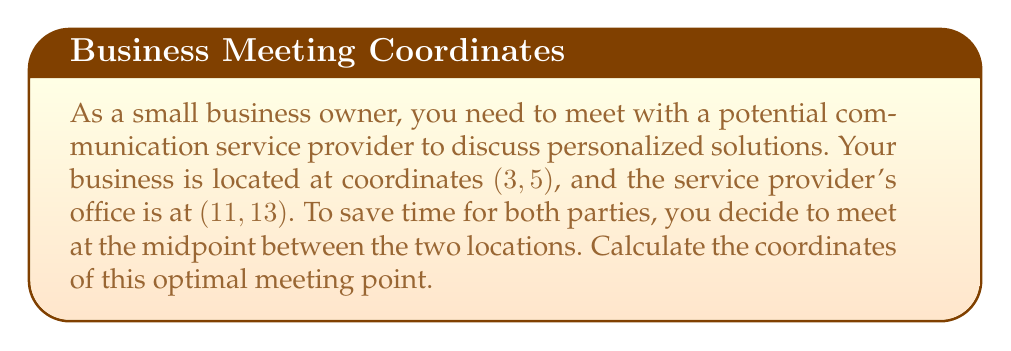Teach me how to tackle this problem. To find the midpoint between two points in a coordinate system, we use the midpoint formula:

$$\text{Midpoint} = (\frac{x_1 + x_2}{2}, \frac{y_1 + y_2}{2})$$

Where $(x_1, y_1)$ is the first point and $(x_2, y_2)$ is the second point.

In this case:
$(x_1, y_1) = (3, 5)$ (your business location)
$(x_2, y_2) = (11, 13)$ (service provider's office)

Let's calculate the x-coordinate of the midpoint:
$$x = \frac{x_1 + x_2}{2} = \frac{3 + 11}{2} = \frac{14}{2} = 7$$

Now, let's calculate the y-coordinate of the midpoint:
$$y = \frac{y_1 + y_2}{2} = \frac{5 + 13}{2} = \frac{18}{2} = 9$$

Therefore, the midpoint coordinates are (7, 9).

[asy]
unitsize(1cm);
dot((3,5));
dot((11,13));
dot((7,9),red);
label("(3,5)", (3,5), SW);
label("(11,13)", (11,13), NE);
label("(7,9)", (7,9), SE);
draw((3,5)--(11,13), dashed);
draw((0,0)--(12,14), Arrow);
draw((0,0)--(0,14), Arrow);
label("x", (12,0), E);
label("y", (0,14), N);
[/asy]
Answer: The optimal meeting point is at coordinates $(7, 9)$. 